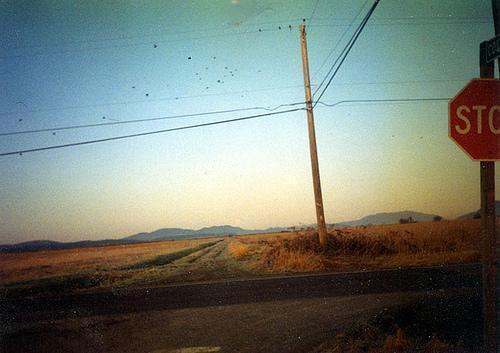How many different directions to the electrical lines go?
Give a very brief answer. 3. How many building?
Give a very brief answer. 0. How many people have on yellow shirts?
Give a very brief answer. 0. 